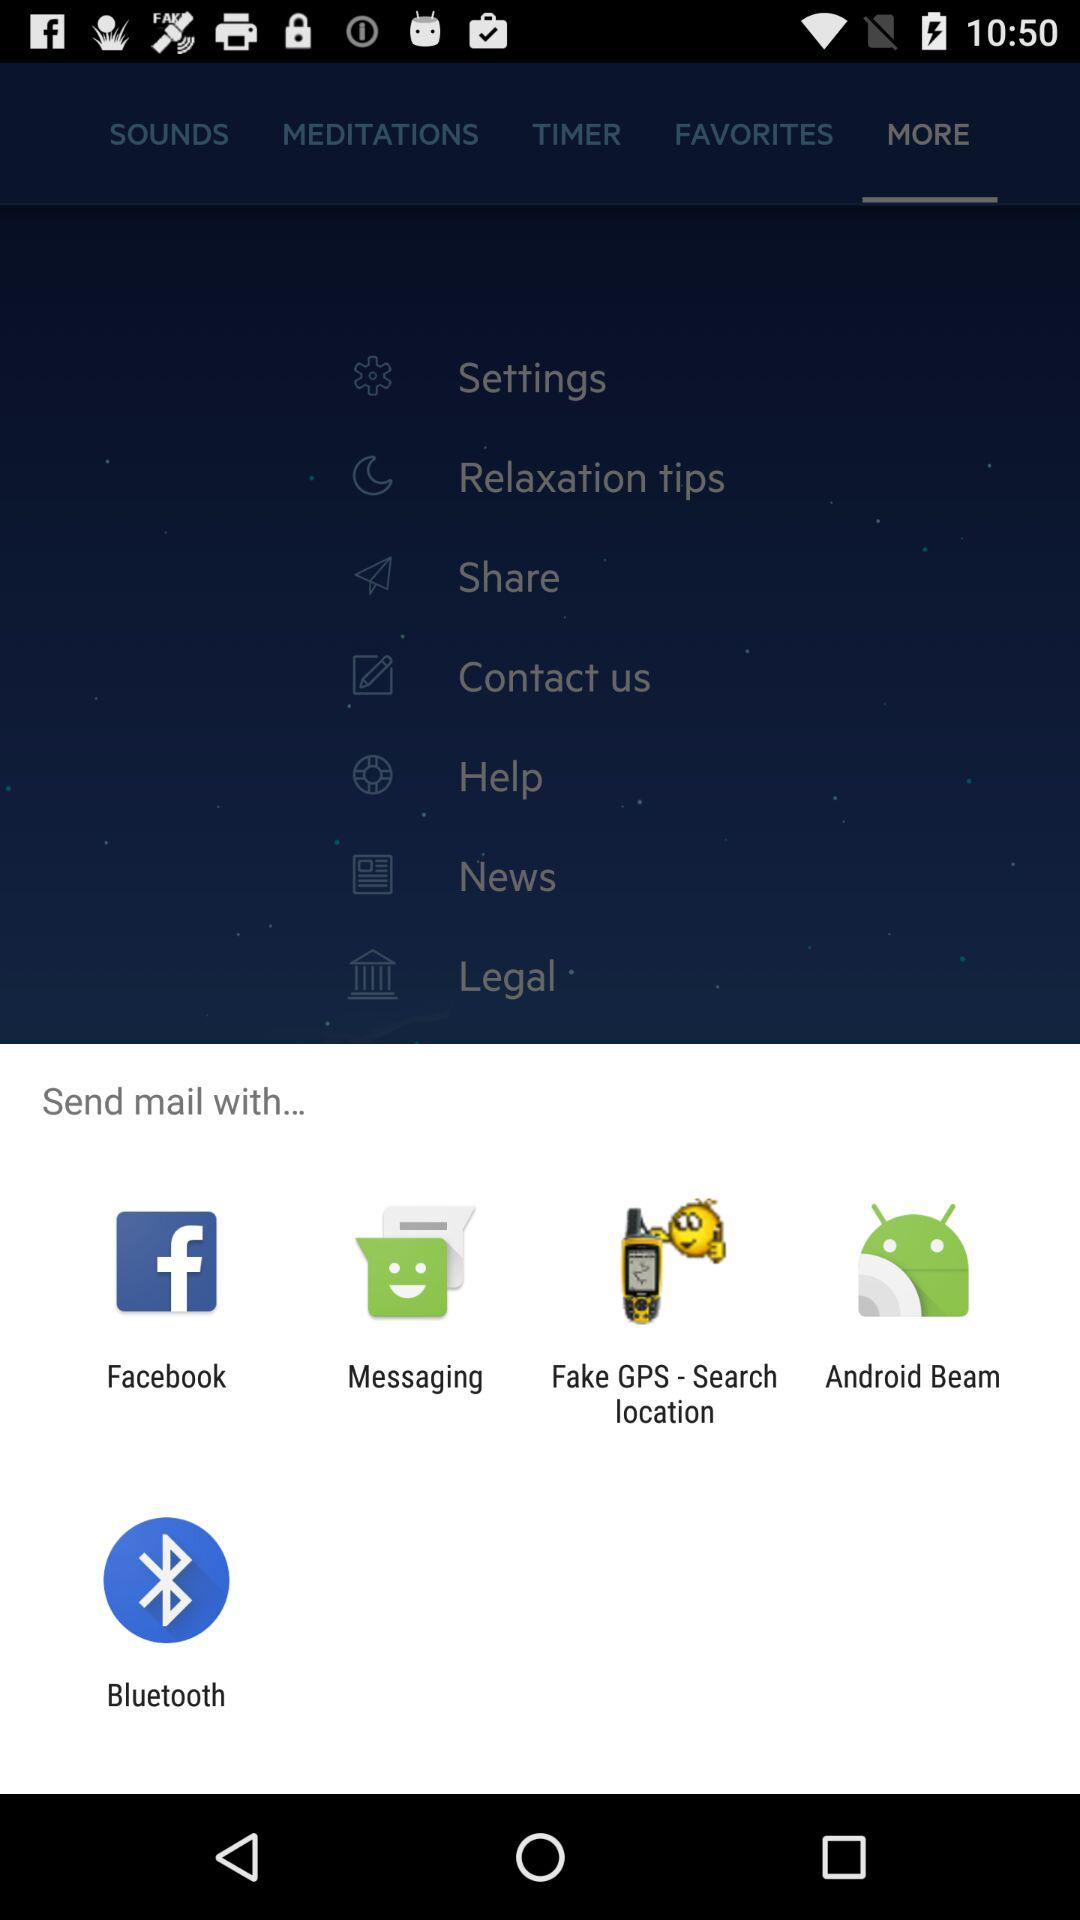What are the options for sending mail? The options are "Facebook", "Messaging", "Fake GPS - Search location", "Android Beam" and "Bluetooth". 